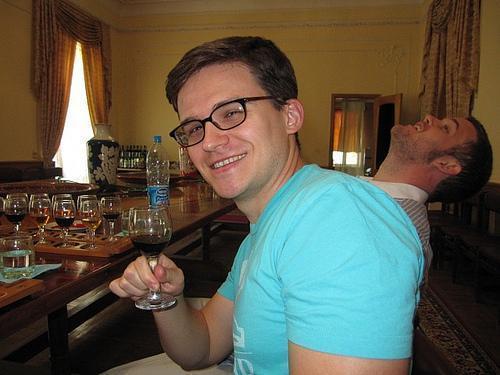How many men are seen?
Give a very brief answer. 2. How many wine glasses can be seen?
Give a very brief answer. 11. 